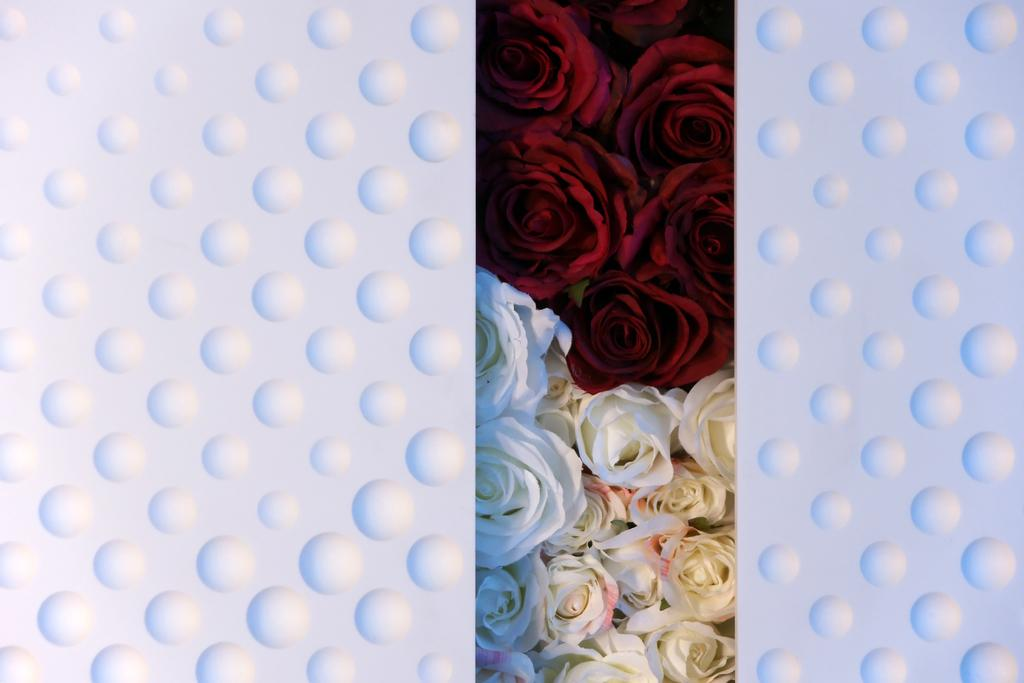What type of living organisms can be seen in the image? There are flowers in the image. What type of coast can be seen in the image? There is no coast present in the image; it features flowers. 